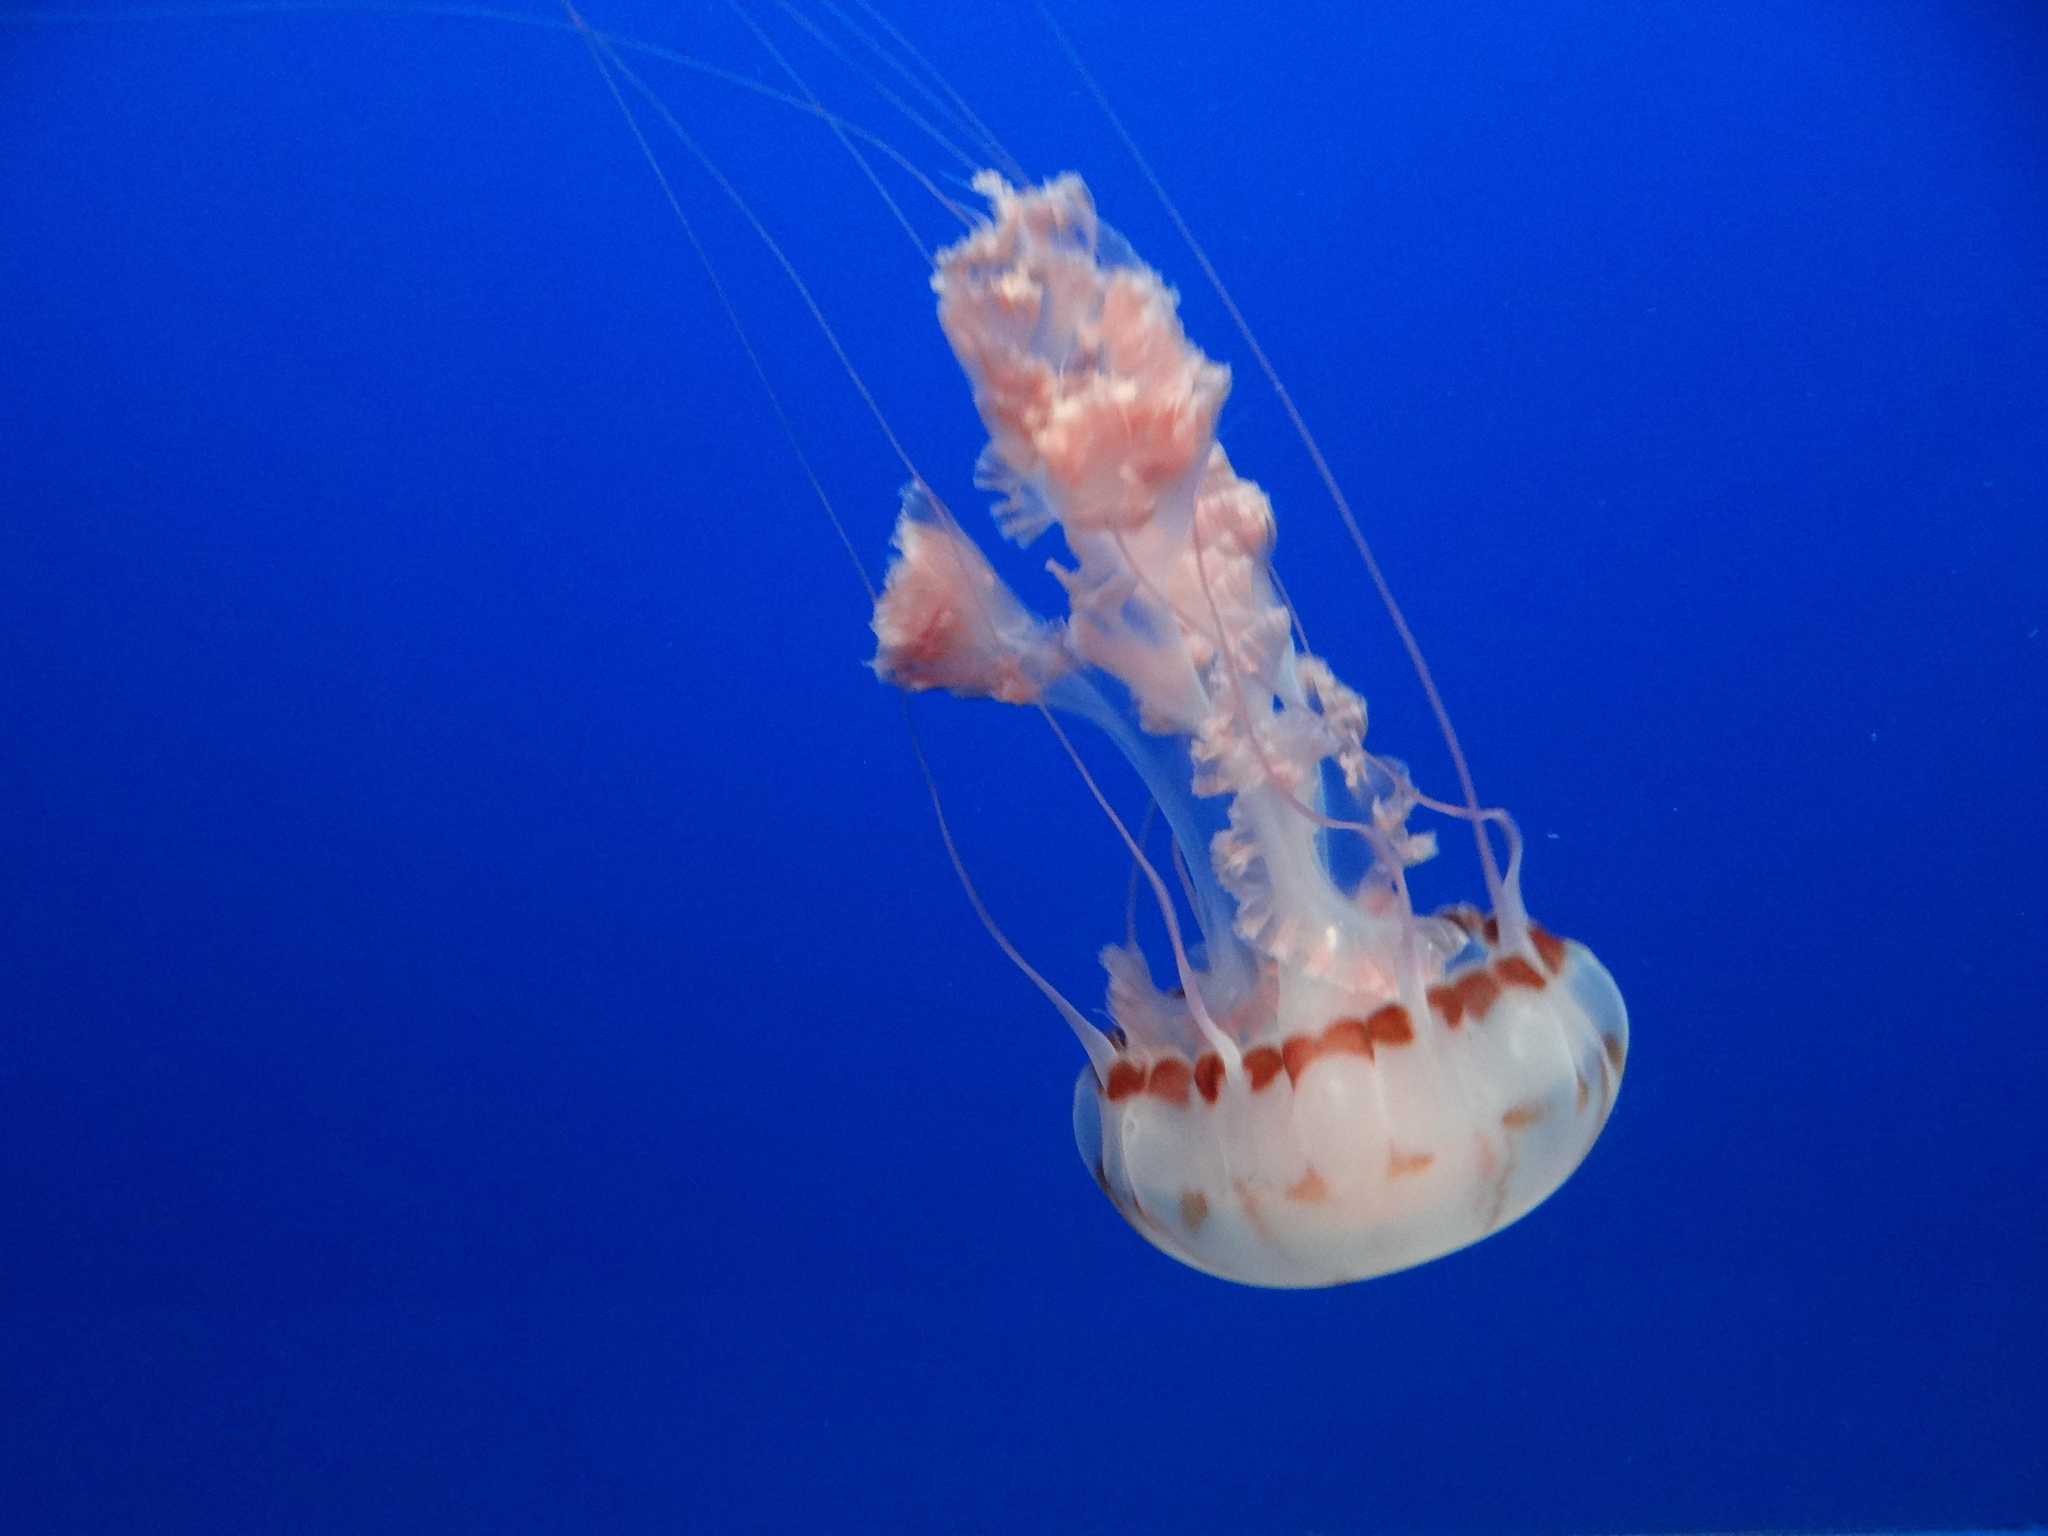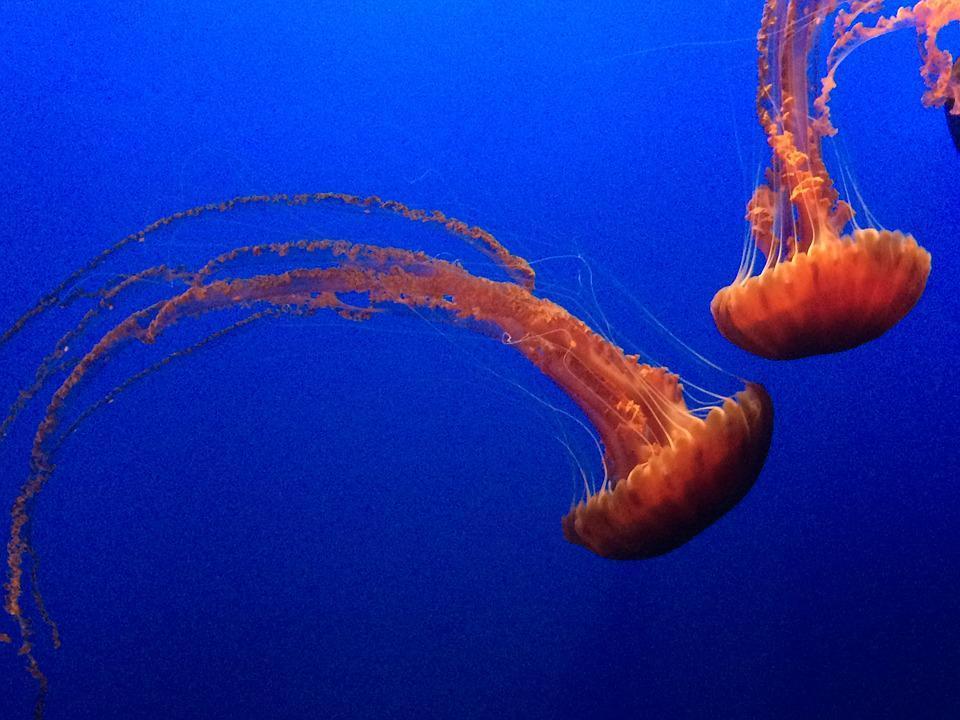The first image is the image on the left, the second image is the image on the right. Evaluate the accuracy of this statement regarding the images: "There are three jellyfish". Is it true? Answer yes or no. Yes. 